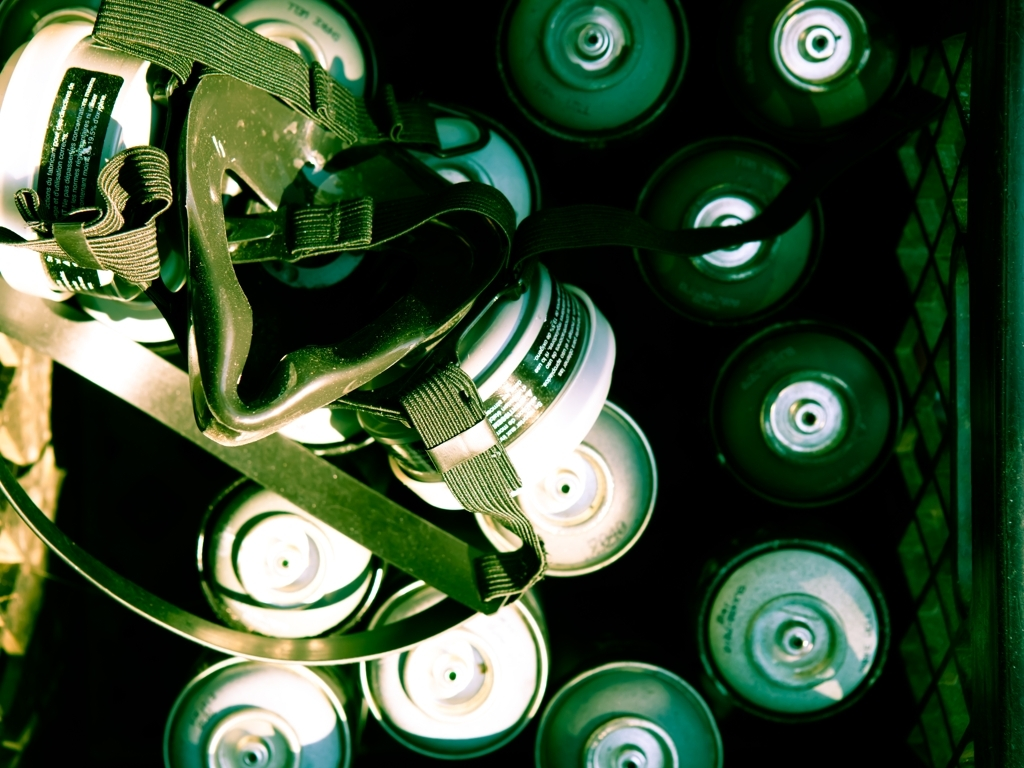What mood does the lighting and color scheme of the image evoke? The lighting casts dramatic shadows, giving the image a somewhat moody or intense atmosphere. The predominance of dark tones and the bright highlights on the metallic surfaces create a stark and focused aesthetic, possibly hinting at a creative and energetic environment. 